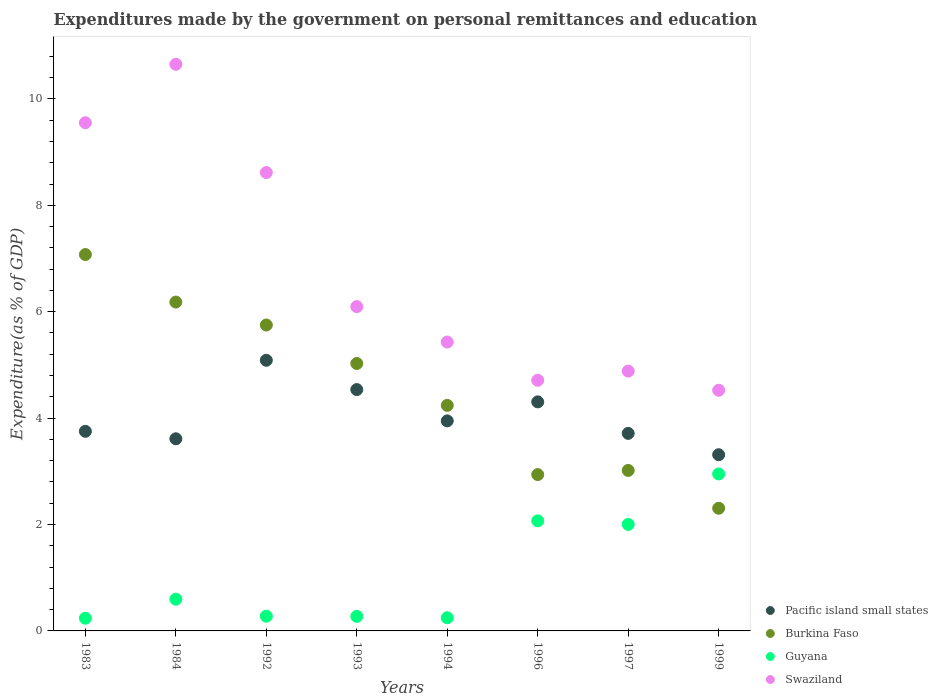How many different coloured dotlines are there?
Your response must be concise. 4. What is the expenditures made by the government on personal remittances and education in Burkina Faso in 1996?
Offer a terse response. 2.94. Across all years, what is the maximum expenditures made by the government on personal remittances and education in Burkina Faso?
Make the answer very short. 7.07. Across all years, what is the minimum expenditures made by the government on personal remittances and education in Burkina Faso?
Give a very brief answer. 2.31. In which year was the expenditures made by the government on personal remittances and education in Burkina Faso minimum?
Provide a succinct answer. 1999. What is the total expenditures made by the government on personal remittances and education in Swaziland in the graph?
Make the answer very short. 54.46. What is the difference between the expenditures made by the government on personal remittances and education in Guyana in 1984 and that in 1996?
Provide a short and direct response. -1.47. What is the difference between the expenditures made by the government on personal remittances and education in Burkina Faso in 1994 and the expenditures made by the government on personal remittances and education in Guyana in 1996?
Provide a succinct answer. 2.17. What is the average expenditures made by the government on personal remittances and education in Guyana per year?
Provide a succinct answer. 1.08. In the year 1983, what is the difference between the expenditures made by the government on personal remittances and education in Burkina Faso and expenditures made by the government on personal remittances and education in Guyana?
Keep it short and to the point. 6.84. What is the ratio of the expenditures made by the government on personal remittances and education in Burkina Faso in 1994 to that in 1996?
Offer a very short reply. 1.44. Is the difference between the expenditures made by the government on personal remittances and education in Burkina Faso in 1983 and 1999 greater than the difference between the expenditures made by the government on personal remittances and education in Guyana in 1983 and 1999?
Offer a terse response. Yes. What is the difference between the highest and the second highest expenditures made by the government on personal remittances and education in Guyana?
Ensure brevity in your answer.  0.88. What is the difference between the highest and the lowest expenditures made by the government on personal remittances and education in Swaziland?
Give a very brief answer. 6.13. In how many years, is the expenditures made by the government on personal remittances and education in Pacific island small states greater than the average expenditures made by the government on personal remittances and education in Pacific island small states taken over all years?
Provide a succinct answer. 3. Is the sum of the expenditures made by the government on personal remittances and education in Pacific island small states in 1984 and 1993 greater than the maximum expenditures made by the government on personal remittances and education in Burkina Faso across all years?
Provide a succinct answer. Yes. Is it the case that in every year, the sum of the expenditures made by the government on personal remittances and education in Swaziland and expenditures made by the government on personal remittances and education in Guyana  is greater than the sum of expenditures made by the government on personal remittances and education in Pacific island small states and expenditures made by the government on personal remittances and education in Burkina Faso?
Offer a very short reply. Yes. Is it the case that in every year, the sum of the expenditures made by the government on personal remittances and education in Guyana and expenditures made by the government on personal remittances and education in Burkina Faso  is greater than the expenditures made by the government on personal remittances and education in Pacific island small states?
Your answer should be very brief. Yes. Does the expenditures made by the government on personal remittances and education in Swaziland monotonically increase over the years?
Keep it short and to the point. No. How many years are there in the graph?
Your answer should be compact. 8. Are the values on the major ticks of Y-axis written in scientific E-notation?
Provide a short and direct response. No. Does the graph contain any zero values?
Keep it short and to the point. No. Does the graph contain grids?
Offer a terse response. No. How many legend labels are there?
Make the answer very short. 4. What is the title of the graph?
Your response must be concise. Expenditures made by the government on personal remittances and education. What is the label or title of the Y-axis?
Your response must be concise. Expenditure(as % of GDP). What is the Expenditure(as % of GDP) in Pacific island small states in 1983?
Your answer should be very brief. 3.75. What is the Expenditure(as % of GDP) of Burkina Faso in 1983?
Ensure brevity in your answer.  7.07. What is the Expenditure(as % of GDP) in Guyana in 1983?
Your answer should be very brief. 0.24. What is the Expenditure(as % of GDP) of Swaziland in 1983?
Offer a terse response. 9.55. What is the Expenditure(as % of GDP) in Pacific island small states in 1984?
Your response must be concise. 3.61. What is the Expenditure(as % of GDP) in Burkina Faso in 1984?
Your response must be concise. 6.18. What is the Expenditure(as % of GDP) of Guyana in 1984?
Provide a succinct answer. 0.6. What is the Expenditure(as % of GDP) in Swaziland in 1984?
Offer a very short reply. 10.65. What is the Expenditure(as % of GDP) in Pacific island small states in 1992?
Provide a succinct answer. 5.09. What is the Expenditure(as % of GDP) in Burkina Faso in 1992?
Offer a very short reply. 5.75. What is the Expenditure(as % of GDP) of Guyana in 1992?
Provide a succinct answer. 0.28. What is the Expenditure(as % of GDP) in Swaziland in 1992?
Your answer should be compact. 8.62. What is the Expenditure(as % of GDP) in Pacific island small states in 1993?
Provide a short and direct response. 4.54. What is the Expenditure(as % of GDP) of Burkina Faso in 1993?
Keep it short and to the point. 5.03. What is the Expenditure(as % of GDP) in Guyana in 1993?
Make the answer very short. 0.27. What is the Expenditure(as % of GDP) in Swaziland in 1993?
Ensure brevity in your answer.  6.1. What is the Expenditure(as % of GDP) of Pacific island small states in 1994?
Ensure brevity in your answer.  3.95. What is the Expenditure(as % of GDP) of Burkina Faso in 1994?
Provide a short and direct response. 4.24. What is the Expenditure(as % of GDP) in Guyana in 1994?
Your response must be concise. 0.25. What is the Expenditure(as % of GDP) in Swaziland in 1994?
Keep it short and to the point. 5.43. What is the Expenditure(as % of GDP) of Pacific island small states in 1996?
Keep it short and to the point. 4.31. What is the Expenditure(as % of GDP) of Burkina Faso in 1996?
Offer a very short reply. 2.94. What is the Expenditure(as % of GDP) in Guyana in 1996?
Your answer should be very brief. 2.07. What is the Expenditure(as % of GDP) of Swaziland in 1996?
Give a very brief answer. 4.71. What is the Expenditure(as % of GDP) in Pacific island small states in 1997?
Your answer should be compact. 3.71. What is the Expenditure(as % of GDP) of Burkina Faso in 1997?
Your answer should be compact. 3.02. What is the Expenditure(as % of GDP) in Guyana in 1997?
Your response must be concise. 2. What is the Expenditure(as % of GDP) in Swaziland in 1997?
Your response must be concise. 4.88. What is the Expenditure(as % of GDP) of Pacific island small states in 1999?
Ensure brevity in your answer.  3.31. What is the Expenditure(as % of GDP) of Burkina Faso in 1999?
Your response must be concise. 2.31. What is the Expenditure(as % of GDP) in Guyana in 1999?
Offer a terse response. 2.95. What is the Expenditure(as % of GDP) in Swaziland in 1999?
Make the answer very short. 4.52. Across all years, what is the maximum Expenditure(as % of GDP) of Pacific island small states?
Provide a succinct answer. 5.09. Across all years, what is the maximum Expenditure(as % of GDP) in Burkina Faso?
Make the answer very short. 7.07. Across all years, what is the maximum Expenditure(as % of GDP) of Guyana?
Ensure brevity in your answer.  2.95. Across all years, what is the maximum Expenditure(as % of GDP) of Swaziland?
Provide a succinct answer. 10.65. Across all years, what is the minimum Expenditure(as % of GDP) in Pacific island small states?
Provide a succinct answer. 3.31. Across all years, what is the minimum Expenditure(as % of GDP) in Burkina Faso?
Make the answer very short. 2.31. Across all years, what is the minimum Expenditure(as % of GDP) in Guyana?
Your answer should be very brief. 0.24. Across all years, what is the minimum Expenditure(as % of GDP) in Swaziland?
Provide a succinct answer. 4.52. What is the total Expenditure(as % of GDP) in Pacific island small states in the graph?
Keep it short and to the point. 32.27. What is the total Expenditure(as % of GDP) in Burkina Faso in the graph?
Provide a short and direct response. 36.53. What is the total Expenditure(as % of GDP) in Guyana in the graph?
Provide a short and direct response. 8.66. What is the total Expenditure(as % of GDP) of Swaziland in the graph?
Your response must be concise. 54.46. What is the difference between the Expenditure(as % of GDP) of Pacific island small states in 1983 and that in 1984?
Keep it short and to the point. 0.14. What is the difference between the Expenditure(as % of GDP) in Burkina Faso in 1983 and that in 1984?
Provide a short and direct response. 0.89. What is the difference between the Expenditure(as % of GDP) in Guyana in 1983 and that in 1984?
Ensure brevity in your answer.  -0.36. What is the difference between the Expenditure(as % of GDP) in Swaziland in 1983 and that in 1984?
Provide a succinct answer. -1.1. What is the difference between the Expenditure(as % of GDP) in Pacific island small states in 1983 and that in 1992?
Ensure brevity in your answer.  -1.34. What is the difference between the Expenditure(as % of GDP) in Burkina Faso in 1983 and that in 1992?
Your answer should be compact. 1.32. What is the difference between the Expenditure(as % of GDP) in Guyana in 1983 and that in 1992?
Provide a short and direct response. -0.04. What is the difference between the Expenditure(as % of GDP) in Swaziland in 1983 and that in 1992?
Ensure brevity in your answer.  0.94. What is the difference between the Expenditure(as % of GDP) of Pacific island small states in 1983 and that in 1993?
Provide a succinct answer. -0.78. What is the difference between the Expenditure(as % of GDP) of Burkina Faso in 1983 and that in 1993?
Offer a very short reply. 2.05. What is the difference between the Expenditure(as % of GDP) in Guyana in 1983 and that in 1993?
Make the answer very short. -0.04. What is the difference between the Expenditure(as % of GDP) in Swaziland in 1983 and that in 1993?
Provide a succinct answer. 3.46. What is the difference between the Expenditure(as % of GDP) of Pacific island small states in 1983 and that in 1994?
Ensure brevity in your answer.  -0.2. What is the difference between the Expenditure(as % of GDP) of Burkina Faso in 1983 and that in 1994?
Provide a succinct answer. 2.84. What is the difference between the Expenditure(as % of GDP) in Guyana in 1983 and that in 1994?
Provide a short and direct response. -0.01. What is the difference between the Expenditure(as % of GDP) in Swaziland in 1983 and that in 1994?
Offer a terse response. 4.12. What is the difference between the Expenditure(as % of GDP) of Pacific island small states in 1983 and that in 1996?
Provide a succinct answer. -0.55. What is the difference between the Expenditure(as % of GDP) in Burkina Faso in 1983 and that in 1996?
Offer a terse response. 4.14. What is the difference between the Expenditure(as % of GDP) of Guyana in 1983 and that in 1996?
Give a very brief answer. -1.83. What is the difference between the Expenditure(as % of GDP) in Swaziland in 1983 and that in 1996?
Provide a short and direct response. 4.84. What is the difference between the Expenditure(as % of GDP) in Pacific island small states in 1983 and that in 1997?
Your answer should be compact. 0.04. What is the difference between the Expenditure(as % of GDP) in Burkina Faso in 1983 and that in 1997?
Offer a terse response. 4.06. What is the difference between the Expenditure(as % of GDP) of Guyana in 1983 and that in 1997?
Your answer should be compact. -1.76. What is the difference between the Expenditure(as % of GDP) in Swaziland in 1983 and that in 1997?
Provide a succinct answer. 4.67. What is the difference between the Expenditure(as % of GDP) of Pacific island small states in 1983 and that in 1999?
Offer a terse response. 0.44. What is the difference between the Expenditure(as % of GDP) in Burkina Faso in 1983 and that in 1999?
Give a very brief answer. 4.77. What is the difference between the Expenditure(as % of GDP) in Guyana in 1983 and that in 1999?
Your answer should be compact. -2.71. What is the difference between the Expenditure(as % of GDP) in Swaziland in 1983 and that in 1999?
Provide a short and direct response. 5.03. What is the difference between the Expenditure(as % of GDP) of Pacific island small states in 1984 and that in 1992?
Ensure brevity in your answer.  -1.48. What is the difference between the Expenditure(as % of GDP) in Burkina Faso in 1984 and that in 1992?
Your answer should be very brief. 0.43. What is the difference between the Expenditure(as % of GDP) of Guyana in 1984 and that in 1992?
Your answer should be very brief. 0.32. What is the difference between the Expenditure(as % of GDP) in Swaziland in 1984 and that in 1992?
Your answer should be very brief. 2.04. What is the difference between the Expenditure(as % of GDP) of Pacific island small states in 1984 and that in 1993?
Your answer should be compact. -0.92. What is the difference between the Expenditure(as % of GDP) of Burkina Faso in 1984 and that in 1993?
Your answer should be very brief. 1.15. What is the difference between the Expenditure(as % of GDP) in Guyana in 1984 and that in 1993?
Offer a terse response. 0.32. What is the difference between the Expenditure(as % of GDP) in Swaziland in 1984 and that in 1993?
Provide a short and direct response. 4.55. What is the difference between the Expenditure(as % of GDP) of Pacific island small states in 1984 and that in 1994?
Provide a short and direct response. -0.34. What is the difference between the Expenditure(as % of GDP) of Burkina Faso in 1984 and that in 1994?
Give a very brief answer. 1.94. What is the difference between the Expenditure(as % of GDP) of Guyana in 1984 and that in 1994?
Make the answer very short. 0.35. What is the difference between the Expenditure(as % of GDP) in Swaziland in 1984 and that in 1994?
Your answer should be compact. 5.22. What is the difference between the Expenditure(as % of GDP) in Pacific island small states in 1984 and that in 1996?
Offer a terse response. -0.69. What is the difference between the Expenditure(as % of GDP) in Burkina Faso in 1984 and that in 1996?
Give a very brief answer. 3.24. What is the difference between the Expenditure(as % of GDP) in Guyana in 1984 and that in 1996?
Ensure brevity in your answer.  -1.47. What is the difference between the Expenditure(as % of GDP) of Swaziland in 1984 and that in 1996?
Provide a short and direct response. 5.94. What is the difference between the Expenditure(as % of GDP) of Pacific island small states in 1984 and that in 1997?
Your answer should be compact. -0.1. What is the difference between the Expenditure(as % of GDP) in Burkina Faso in 1984 and that in 1997?
Ensure brevity in your answer.  3.16. What is the difference between the Expenditure(as % of GDP) in Guyana in 1984 and that in 1997?
Give a very brief answer. -1.41. What is the difference between the Expenditure(as % of GDP) of Swaziland in 1984 and that in 1997?
Offer a very short reply. 5.77. What is the difference between the Expenditure(as % of GDP) in Pacific island small states in 1984 and that in 1999?
Give a very brief answer. 0.3. What is the difference between the Expenditure(as % of GDP) in Burkina Faso in 1984 and that in 1999?
Provide a succinct answer. 3.88. What is the difference between the Expenditure(as % of GDP) of Guyana in 1984 and that in 1999?
Keep it short and to the point. -2.35. What is the difference between the Expenditure(as % of GDP) in Swaziland in 1984 and that in 1999?
Offer a terse response. 6.13. What is the difference between the Expenditure(as % of GDP) of Pacific island small states in 1992 and that in 1993?
Your answer should be compact. 0.55. What is the difference between the Expenditure(as % of GDP) of Burkina Faso in 1992 and that in 1993?
Keep it short and to the point. 0.72. What is the difference between the Expenditure(as % of GDP) of Guyana in 1992 and that in 1993?
Your response must be concise. 0. What is the difference between the Expenditure(as % of GDP) of Swaziland in 1992 and that in 1993?
Offer a very short reply. 2.52. What is the difference between the Expenditure(as % of GDP) of Pacific island small states in 1992 and that in 1994?
Offer a terse response. 1.14. What is the difference between the Expenditure(as % of GDP) of Burkina Faso in 1992 and that in 1994?
Your answer should be compact. 1.51. What is the difference between the Expenditure(as % of GDP) of Guyana in 1992 and that in 1994?
Offer a terse response. 0.03. What is the difference between the Expenditure(as % of GDP) of Swaziland in 1992 and that in 1994?
Give a very brief answer. 3.19. What is the difference between the Expenditure(as % of GDP) in Pacific island small states in 1992 and that in 1996?
Offer a terse response. 0.78. What is the difference between the Expenditure(as % of GDP) in Burkina Faso in 1992 and that in 1996?
Make the answer very short. 2.81. What is the difference between the Expenditure(as % of GDP) in Guyana in 1992 and that in 1996?
Your answer should be very brief. -1.79. What is the difference between the Expenditure(as % of GDP) in Swaziland in 1992 and that in 1996?
Provide a succinct answer. 3.9. What is the difference between the Expenditure(as % of GDP) of Pacific island small states in 1992 and that in 1997?
Keep it short and to the point. 1.37. What is the difference between the Expenditure(as % of GDP) in Burkina Faso in 1992 and that in 1997?
Keep it short and to the point. 2.73. What is the difference between the Expenditure(as % of GDP) in Guyana in 1992 and that in 1997?
Offer a terse response. -1.73. What is the difference between the Expenditure(as % of GDP) of Swaziland in 1992 and that in 1997?
Your answer should be very brief. 3.73. What is the difference between the Expenditure(as % of GDP) in Pacific island small states in 1992 and that in 1999?
Keep it short and to the point. 1.78. What is the difference between the Expenditure(as % of GDP) of Burkina Faso in 1992 and that in 1999?
Provide a short and direct response. 3.44. What is the difference between the Expenditure(as % of GDP) of Guyana in 1992 and that in 1999?
Your response must be concise. -2.67. What is the difference between the Expenditure(as % of GDP) in Swaziland in 1992 and that in 1999?
Give a very brief answer. 4.09. What is the difference between the Expenditure(as % of GDP) of Pacific island small states in 1993 and that in 1994?
Give a very brief answer. 0.59. What is the difference between the Expenditure(as % of GDP) of Burkina Faso in 1993 and that in 1994?
Your response must be concise. 0.79. What is the difference between the Expenditure(as % of GDP) in Guyana in 1993 and that in 1994?
Ensure brevity in your answer.  0.03. What is the difference between the Expenditure(as % of GDP) of Swaziland in 1993 and that in 1994?
Make the answer very short. 0.67. What is the difference between the Expenditure(as % of GDP) in Pacific island small states in 1993 and that in 1996?
Provide a short and direct response. 0.23. What is the difference between the Expenditure(as % of GDP) of Burkina Faso in 1993 and that in 1996?
Ensure brevity in your answer.  2.09. What is the difference between the Expenditure(as % of GDP) in Guyana in 1993 and that in 1996?
Offer a very short reply. -1.8. What is the difference between the Expenditure(as % of GDP) of Swaziland in 1993 and that in 1996?
Ensure brevity in your answer.  1.38. What is the difference between the Expenditure(as % of GDP) in Pacific island small states in 1993 and that in 1997?
Your answer should be compact. 0.82. What is the difference between the Expenditure(as % of GDP) of Burkina Faso in 1993 and that in 1997?
Offer a terse response. 2.01. What is the difference between the Expenditure(as % of GDP) of Guyana in 1993 and that in 1997?
Give a very brief answer. -1.73. What is the difference between the Expenditure(as % of GDP) of Swaziland in 1993 and that in 1997?
Give a very brief answer. 1.21. What is the difference between the Expenditure(as % of GDP) in Pacific island small states in 1993 and that in 1999?
Give a very brief answer. 1.22. What is the difference between the Expenditure(as % of GDP) of Burkina Faso in 1993 and that in 1999?
Make the answer very short. 2.72. What is the difference between the Expenditure(as % of GDP) in Guyana in 1993 and that in 1999?
Your answer should be very brief. -2.68. What is the difference between the Expenditure(as % of GDP) of Swaziland in 1993 and that in 1999?
Ensure brevity in your answer.  1.57. What is the difference between the Expenditure(as % of GDP) of Pacific island small states in 1994 and that in 1996?
Ensure brevity in your answer.  -0.36. What is the difference between the Expenditure(as % of GDP) of Burkina Faso in 1994 and that in 1996?
Keep it short and to the point. 1.3. What is the difference between the Expenditure(as % of GDP) of Guyana in 1994 and that in 1996?
Provide a succinct answer. -1.82. What is the difference between the Expenditure(as % of GDP) of Swaziland in 1994 and that in 1996?
Ensure brevity in your answer.  0.72. What is the difference between the Expenditure(as % of GDP) of Pacific island small states in 1994 and that in 1997?
Your answer should be very brief. 0.23. What is the difference between the Expenditure(as % of GDP) in Burkina Faso in 1994 and that in 1997?
Keep it short and to the point. 1.22. What is the difference between the Expenditure(as % of GDP) of Guyana in 1994 and that in 1997?
Offer a terse response. -1.75. What is the difference between the Expenditure(as % of GDP) in Swaziland in 1994 and that in 1997?
Offer a terse response. 0.55. What is the difference between the Expenditure(as % of GDP) in Pacific island small states in 1994 and that in 1999?
Your response must be concise. 0.64. What is the difference between the Expenditure(as % of GDP) in Burkina Faso in 1994 and that in 1999?
Provide a short and direct response. 1.93. What is the difference between the Expenditure(as % of GDP) in Guyana in 1994 and that in 1999?
Ensure brevity in your answer.  -2.7. What is the difference between the Expenditure(as % of GDP) of Swaziland in 1994 and that in 1999?
Your answer should be compact. 0.91. What is the difference between the Expenditure(as % of GDP) in Pacific island small states in 1996 and that in 1997?
Your answer should be very brief. 0.59. What is the difference between the Expenditure(as % of GDP) of Burkina Faso in 1996 and that in 1997?
Provide a succinct answer. -0.08. What is the difference between the Expenditure(as % of GDP) of Guyana in 1996 and that in 1997?
Offer a very short reply. 0.07. What is the difference between the Expenditure(as % of GDP) of Swaziland in 1996 and that in 1997?
Your answer should be compact. -0.17. What is the difference between the Expenditure(as % of GDP) of Burkina Faso in 1996 and that in 1999?
Make the answer very short. 0.63. What is the difference between the Expenditure(as % of GDP) in Guyana in 1996 and that in 1999?
Offer a very short reply. -0.88. What is the difference between the Expenditure(as % of GDP) in Swaziland in 1996 and that in 1999?
Your answer should be very brief. 0.19. What is the difference between the Expenditure(as % of GDP) of Pacific island small states in 1997 and that in 1999?
Provide a short and direct response. 0.4. What is the difference between the Expenditure(as % of GDP) of Burkina Faso in 1997 and that in 1999?
Keep it short and to the point. 0.71. What is the difference between the Expenditure(as % of GDP) of Guyana in 1997 and that in 1999?
Your answer should be very brief. -0.95. What is the difference between the Expenditure(as % of GDP) of Swaziland in 1997 and that in 1999?
Your answer should be very brief. 0.36. What is the difference between the Expenditure(as % of GDP) of Pacific island small states in 1983 and the Expenditure(as % of GDP) of Burkina Faso in 1984?
Your answer should be compact. -2.43. What is the difference between the Expenditure(as % of GDP) in Pacific island small states in 1983 and the Expenditure(as % of GDP) in Guyana in 1984?
Give a very brief answer. 3.16. What is the difference between the Expenditure(as % of GDP) in Pacific island small states in 1983 and the Expenditure(as % of GDP) in Swaziland in 1984?
Keep it short and to the point. -6.9. What is the difference between the Expenditure(as % of GDP) in Burkina Faso in 1983 and the Expenditure(as % of GDP) in Guyana in 1984?
Offer a terse response. 6.48. What is the difference between the Expenditure(as % of GDP) of Burkina Faso in 1983 and the Expenditure(as % of GDP) of Swaziland in 1984?
Your response must be concise. -3.58. What is the difference between the Expenditure(as % of GDP) of Guyana in 1983 and the Expenditure(as % of GDP) of Swaziland in 1984?
Give a very brief answer. -10.41. What is the difference between the Expenditure(as % of GDP) of Pacific island small states in 1983 and the Expenditure(as % of GDP) of Burkina Faso in 1992?
Give a very brief answer. -2. What is the difference between the Expenditure(as % of GDP) of Pacific island small states in 1983 and the Expenditure(as % of GDP) of Guyana in 1992?
Keep it short and to the point. 3.48. What is the difference between the Expenditure(as % of GDP) in Pacific island small states in 1983 and the Expenditure(as % of GDP) in Swaziland in 1992?
Give a very brief answer. -4.86. What is the difference between the Expenditure(as % of GDP) in Burkina Faso in 1983 and the Expenditure(as % of GDP) in Guyana in 1992?
Give a very brief answer. 6.8. What is the difference between the Expenditure(as % of GDP) of Burkina Faso in 1983 and the Expenditure(as % of GDP) of Swaziland in 1992?
Your answer should be very brief. -1.54. What is the difference between the Expenditure(as % of GDP) in Guyana in 1983 and the Expenditure(as % of GDP) in Swaziland in 1992?
Make the answer very short. -8.38. What is the difference between the Expenditure(as % of GDP) in Pacific island small states in 1983 and the Expenditure(as % of GDP) in Burkina Faso in 1993?
Provide a short and direct response. -1.27. What is the difference between the Expenditure(as % of GDP) in Pacific island small states in 1983 and the Expenditure(as % of GDP) in Guyana in 1993?
Give a very brief answer. 3.48. What is the difference between the Expenditure(as % of GDP) of Pacific island small states in 1983 and the Expenditure(as % of GDP) of Swaziland in 1993?
Ensure brevity in your answer.  -2.34. What is the difference between the Expenditure(as % of GDP) in Burkina Faso in 1983 and the Expenditure(as % of GDP) in Guyana in 1993?
Your answer should be very brief. 6.8. What is the difference between the Expenditure(as % of GDP) in Burkina Faso in 1983 and the Expenditure(as % of GDP) in Swaziland in 1993?
Your response must be concise. 0.98. What is the difference between the Expenditure(as % of GDP) in Guyana in 1983 and the Expenditure(as % of GDP) in Swaziland in 1993?
Provide a short and direct response. -5.86. What is the difference between the Expenditure(as % of GDP) in Pacific island small states in 1983 and the Expenditure(as % of GDP) in Burkina Faso in 1994?
Provide a succinct answer. -0.49. What is the difference between the Expenditure(as % of GDP) of Pacific island small states in 1983 and the Expenditure(as % of GDP) of Guyana in 1994?
Ensure brevity in your answer.  3.5. What is the difference between the Expenditure(as % of GDP) of Pacific island small states in 1983 and the Expenditure(as % of GDP) of Swaziland in 1994?
Ensure brevity in your answer.  -1.68. What is the difference between the Expenditure(as % of GDP) in Burkina Faso in 1983 and the Expenditure(as % of GDP) in Guyana in 1994?
Make the answer very short. 6.83. What is the difference between the Expenditure(as % of GDP) of Burkina Faso in 1983 and the Expenditure(as % of GDP) of Swaziland in 1994?
Your response must be concise. 1.64. What is the difference between the Expenditure(as % of GDP) of Guyana in 1983 and the Expenditure(as % of GDP) of Swaziland in 1994?
Keep it short and to the point. -5.19. What is the difference between the Expenditure(as % of GDP) of Pacific island small states in 1983 and the Expenditure(as % of GDP) of Burkina Faso in 1996?
Make the answer very short. 0.81. What is the difference between the Expenditure(as % of GDP) in Pacific island small states in 1983 and the Expenditure(as % of GDP) in Guyana in 1996?
Give a very brief answer. 1.68. What is the difference between the Expenditure(as % of GDP) in Pacific island small states in 1983 and the Expenditure(as % of GDP) in Swaziland in 1996?
Make the answer very short. -0.96. What is the difference between the Expenditure(as % of GDP) in Burkina Faso in 1983 and the Expenditure(as % of GDP) in Guyana in 1996?
Make the answer very short. 5. What is the difference between the Expenditure(as % of GDP) in Burkina Faso in 1983 and the Expenditure(as % of GDP) in Swaziland in 1996?
Make the answer very short. 2.36. What is the difference between the Expenditure(as % of GDP) of Guyana in 1983 and the Expenditure(as % of GDP) of Swaziland in 1996?
Offer a terse response. -4.47. What is the difference between the Expenditure(as % of GDP) of Pacific island small states in 1983 and the Expenditure(as % of GDP) of Burkina Faso in 1997?
Your answer should be compact. 0.74. What is the difference between the Expenditure(as % of GDP) in Pacific island small states in 1983 and the Expenditure(as % of GDP) in Guyana in 1997?
Your answer should be very brief. 1.75. What is the difference between the Expenditure(as % of GDP) in Pacific island small states in 1983 and the Expenditure(as % of GDP) in Swaziland in 1997?
Make the answer very short. -1.13. What is the difference between the Expenditure(as % of GDP) in Burkina Faso in 1983 and the Expenditure(as % of GDP) in Guyana in 1997?
Your response must be concise. 5.07. What is the difference between the Expenditure(as % of GDP) in Burkina Faso in 1983 and the Expenditure(as % of GDP) in Swaziland in 1997?
Offer a very short reply. 2.19. What is the difference between the Expenditure(as % of GDP) in Guyana in 1983 and the Expenditure(as % of GDP) in Swaziland in 1997?
Offer a terse response. -4.65. What is the difference between the Expenditure(as % of GDP) in Pacific island small states in 1983 and the Expenditure(as % of GDP) in Burkina Faso in 1999?
Provide a short and direct response. 1.45. What is the difference between the Expenditure(as % of GDP) in Pacific island small states in 1983 and the Expenditure(as % of GDP) in Guyana in 1999?
Offer a very short reply. 0.8. What is the difference between the Expenditure(as % of GDP) of Pacific island small states in 1983 and the Expenditure(as % of GDP) of Swaziland in 1999?
Give a very brief answer. -0.77. What is the difference between the Expenditure(as % of GDP) in Burkina Faso in 1983 and the Expenditure(as % of GDP) in Guyana in 1999?
Ensure brevity in your answer.  4.12. What is the difference between the Expenditure(as % of GDP) of Burkina Faso in 1983 and the Expenditure(as % of GDP) of Swaziland in 1999?
Keep it short and to the point. 2.55. What is the difference between the Expenditure(as % of GDP) in Guyana in 1983 and the Expenditure(as % of GDP) in Swaziland in 1999?
Your answer should be compact. -4.29. What is the difference between the Expenditure(as % of GDP) in Pacific island small states in 1984 and the Expenditure(as % of GDP) in Burkina Faso in 1992?
Offer a very short reply. -2.14. What is the difference between the Expenditure(as % of GDP) of Pacific island small states in 1984 and the Expenditure(as % of GDP) of Guyana in 1992?
Ensure brevity in your answer.  3.33. What is the difference between the Expenditure(as % of GDP) in Pacific island small states in 1984 and the Expenditure(as % of GDP) in Swaziland in 1992?
Give a very brief answer. -5. What is the difference between the Expenditure(as % of GDP) in Burkina Faso in 1984 and the Expenditure(as % of GDP) in Guyana in 1992?
Ensure brevity in your answer.  5.9. What is the difference between the Expenditure(as % of GDP) in Burkina Faso in 1984 and the Expenditure(as % of GDP) in Swaziland in 1992?
Keep it short and to the point. -2.43. What is the difference between the Expenditure(as % of GDP) of Guyana in 1984 and the Expenditure(as % of GDP) of Swaziland in 1992?
Provide a short and direct response. -8.02. What is the difference between the Expenditure(as % of GDP) in Pacific island small states in 1984 and the Expenditure(as % of GDP) in Burkina Faso in 1993?
Your response must be concise. -1.42. What is the difference between the Expenditure(as % of GDP) in Pacific island small states in 1984 and the Expenditure(as % of GDP) in Guyana in 1993?
Make the answer very short. 3.34. What is the difference between the Expenditure(as % of GDP) in Pacific island small states in 1984 and the Expenditure(as % of GDP) in Swaziland in 1993?
Offer a very short reply. -2.48. What is the difference between the Expenditure(as % of GDP) in Burkina Faso in 1984 and the Expenditure(as % of GDP) in Guyana in 1993?
Make the answer very short. 5.91. What is the difference between the Expenditure(as % of GDP) in Burkina Faso in 1984 and the Expenditure(as % of GDP) in Swaziland in 1993?
Your response must be concise. 0.09. What is the difference between the Expenditure(as % of GDP) in Guyana in 1984 and the Expenditure(as % of GDP) in Swaziland in 1993?
Offer a terse response. -5.5. What is the difference between the Expenditure(as % of GDP) in Pacific island small states in 1984 and the Expenditure(as % of GDP) in Burkina Faso in 1994?
Offer a terse response. -0.63. What is the difference between the Expenditure(as % of GDP) in Pacific island small states in 1984 and the Expenditure(as % of GDP) in Guyana in 1994?
Offer a very short reply. 3.36. What is the difference between the Expenditure(as % of GDP) of Pacific island small states in 1984 and the Expenditure(as % of GDP) of Swaziland in 1994?
Ensure brevity in your answer.  -1.82. What is the difference between the Expenditure(as % of GDP) of Burkina Faso in 1984 and the Expenditure(as % of GDP) of Guyana in 1994?
Keep it short and to the point. 5.93. What is the difference between the Expenditure(as % of GDP) of Burkina Faso in 1984 and the Expenditure(as % of GDP) of Swaziland in 1994?
Provide a short and direct response. 0.75. What is the difference between the Expenditure(as % of GDP) in Guyana in 1984 and the Expenditure(as % of GDP) in Swaziland in 1994?
Offer a very short reply. -4.83. What is the difference between the Expenditure(as % of GDP) of Pacific island small states in 1984 and the Expenditure(as % of GDP) of Burkina Faso in 1996?
Ensure brevity in your answer.  0.67. What is the difference between the Expenditure(as % of GDP) in Pacific island small states in 1984 and the Expenditure(as % of GDP) in Guyana in 1996?
Make the answer very short. 1.54. What is the difference between the Expenditure(as % of GDP) of Pacific island small states in 1984 and the Expenditure(as % of GDP) of Swaziland in 1996?
Make the answer very short. -1.1. What is the difference between the Expenditure(as % of GDP) of Burkina Faso in 1984 and the Expenditure(as % of GDP) of Guyana in 1996?
Offer a terse response. 4.11. What is the difference between the Expenditure(as % of GDP) of Burkina Faso in 1984 and the Expenditure(as % of GDP) of Swaziland in 1996?
Give a very brief answer. 1.47. What is the difference between the Expenditure(as % of GDP) of Guyana in 1984 and the Expenditure(as % of GDP) of Swaziland in 1996?
Provide a short and direct response. -4.12. What is the difference between the Expenditure(as % of GDP) in Pacific island small states in 1984 and the Expenditure(as % of GDP) in Burkina Faso in 1997?
Your answer should be very brief. 0.59. What is the difference between the Expenditure(as % of GDP) in Pacific island small states in 1984 and the Expenditure(as % of GDP) in Guyana in 1997?
Keep it short and to the point. 1.61. What is the difference between the Expenditure(as % of GDP) in Pacific island small states in 1984 and the Expenditure(as % of GDP) in Swaziland in 1997?
Make the answer very short. -1.27. What is the difference between the Expenditure(as % of GDP) in Burkina Faso in 1984 and the Expenditure(as % of GDP) in Guyana in 1997?
Provide a succinct answer. 4.18. What is the difference between the Expenditure(as % of GDP) of Burkina Faso in 1984 and the Expenditure(as % of GDP) of Swaziland in 1997?
Your answer should be very brief. 1.3. What is the difference between the Expenditure(as % of GDP) of Guyana in 1984 and the Expenditure(as % of GDP) of Swaziland in 1997?
Make the answer very short. -4.29. What is the difference between the Expenditure(as % of GDP) in Pacific island small states in 1984 and the Expenditure(as % of GDP) in Burkina Faso in 1999?
Provide a short and direct response. 1.31. What is the difference between the Expenditure(as % of GDP) of Pacific island small states in 1984 and the Expenditure(as % of GDP) of Guyana in 1999?
Offer a terse response. 0.66. What is the difference between the Expenditure(as % of GDP) in Pacific island small states in 1984 and the Expenditure(as % of GDP) in Swaziland in 1999?
Ensure brevity in your answer.  -0.91. What is the difference between the Expenditure(as % of GDP) in Burkina Faso in 1984 and the Expenditure(as % of GDP) in Guyana in 1999?
Your answer should be compact. 3.23. What is the difference between the Expenditure(as % of GDP) in Burkina Faso in 1984 and the Expenditure(as % of GDP) in Swaziland in 1999?
Your answer should be compact. 1.66. What is the difference between the Expenditure(as % of GDP) in Guyana in 1984 and the Expenditure(as % of GDP) in Swaziland in 1999?
Your answer should be very brief. -3.93. What is the difference between the Expenditure(as % of GDP) of Pacific island small states in 1992 and the Expenditure(as % of GDP) of Burkina Faso in 1993?
Provide a short and direct response. 0.06. What is the difference between the Expenditure(as % of GDP) of Pacific island small states in 1992 and the Expenditure(as % of GDP) of Guyana in 1993?
Keep it short and to the point. 4.81. What is the difference between the Expenditure(as % of GDP) of Pacific island small states in 1992 and the Expenditure(as % of GDP) of Swaziland in 1993?
Your answer should be very brief. -1.01. What is the difference between the Expenditure(as % of GDP) of Burkina Faso in 1992 and the Expenditure(as % of GDP) of Guyana in 1993?
Provide a short and direct response. 5.48. What is the difference between the Expenditure(as % of GDP) in Burkina Faso in 1992 and the Expenditure(as % of GDP) in Swaziland in 1993?
Your response must be concise. -0.35. What is the difference between the Expenditure(as % of GDP) of Guyana in 1992 and the Expenditure(as % of GDP) of Swaziland in 1993?
Your response must be concise. -5.82. What is the difference between the Expenditure(as % of GDP) of Pacific island small states in 1992 and the Expenditure(as % of GDP) of Burkina Faso in 1994?
Provide a short and direct response. 0.85. What is the difference between the Expenditure(as % of GDP) of Pacific island small states in 1992 and the Expenditure(as % of GDP) of Guyana in 1994?
Keep it short and to the point. 4.84. What is the difference between the Expenditure(as % of GDP) of Pacific island small states in 1992 and the Expenditure(as % of GDP) of Swaziland in 1994?
Offer a very short reply. -0.34. What is the difference between the Expenditure(as % of GDP) in Burkina Faso in 1992 and the Expenditure(as % of GDP) in Guyana in 1994?
Your answer should be very brief. 5.5. What is the difference between the Expenditure(as % of GDP) of Burkina Faso in 1992 and the Expenditure(as % of GDP) of Swaziland in 1994?
Make the answer very short. 0.32. What is the difference between the Expenditure(as % of GDP) in Guyana in 1992 and the Expenditure(as % of GDP) in Swaziland in 1994?
Offer a terse response. -5.15. What is the difference between the Expenditure(as % of GDP) of Pacific island small states in 1992 and the Expenditure(as % of GDP) of Burkina Faso in 1996?
Keep it short and to the point. 2.15. What is the difference between the Expenditure(as % of GDP) of Pacific island small states in 1992 and the Expenditure(as % of GDP) of Guyana in 1996?
Make the answer very short. 3.02. What is the difference between the Expenditure(as % of GDP) in Pacific island small states in 1992 and the Expenditure(as % of GDP) in Swaziland in 1996?
Ensure brevity in your answer.  0.38. What is the difference between the Expenditure(as % of GDP) of Burkina Faso in 1992 and the Expenditure(as % of GDP) of Guyana in 1996?
Offer a very short reply. 3.68. What is the difference between the Expenditure(as % of GDP) in Burkina Faso in 1992 and the Expenditure(as % of GDP) in Swaziland in 1996?
Your answer should be compact. 1.04. What is the difference between the Expenditure(as % of GDP) of Guyana in 1992 and the Expenditure(as % of GDP) of Swaziland in 1996?
Keep it short and to the point. -4.43. What is the difference between the Expenditure(as % of GDP) of Pacific island small states in 1992 and the Expenditure(as % of GDP) of Burkina Faso in 1997?
Give a very brief answer. 2.07. What is the difference between the Expenditure(as % of GDP) of Pacific island small states in 1992 and the Expenditure(as % of GDP) of Guyana in 1997?
Keep it short and to the point. 3.08. What is the difference between the Expenditure(as % of GDP) in Pacific island small states in 1992 and the Expenditure(as % of GDP) in Swaziland in 1997?
Your answer should be very brief. 0.2. What is the difference between the Expenditure(as % of GDP) of Burkina Faso in 1992 and the Expenditure(as % of GDP) of Guyana in 1997?
Offer a very short reply. 3.75. What is the difference between the Expenditure(as % of GDP) in Burkina Faso in 1992 and the Expenditure(as % of GDP) in Swaziland in 1997?
Keep it short and to the point. 0.87. What is the difference between the Expenditure(as % of GDP) in Guyana in 1992 and the Expenditure(as % of GDP) in Swaziland in 1997?
Provide a succinct answer. -4.61. What is the difference between the Expenditure(as % of GDP) in Pacific island small states in 1992 and the Expenditure(as % of GDP) in Burkina Faso in 1999?
Ensure brevity in your answer.  2.78. What is the difference between the Expenditure(as % of GDP) of Pacific island small states in 1992 and the Expenditure(as % of GDP) of Guyana in 1999?
Offer a terse response. 2.14. What is the difference between the Expenditure(as % of GDP) of Pacific island small states in 1992 and the Expenditure(as % of GDP) of Swaziland in 1999?
Give a very brief answer. 0.56. What is the difference between the Expenditure(as % of GDP) of Burkina Faso in 1992 and the Expenditure(as % of GDP) of Guyana in 1999?
Offer a very short reply. 2.8. What is the difference between the Expenditure(as % of GDP) in Burkina Faso in 1992 and the Expenditure(as % of GDP) in Swaziland in 1999?
Give a very brief answer. 1.23. What is the difference between the Expenditure(as % of GDP) of Guyana in 1992 and the Expenditure(as % of GDP) of Swaziland in 1999?
Provide a succinct answer. -4.25. What is the difference between the Expenditure(as % of GDP) in Pacific island small states in 1993 and the Expenditure(as % of GDP) in Burkina Faso in 1994?
Ensure brevity in your answer.  0.3. What is the difference between the Expenditure(as % of GDP) in Pacific island small states in 1993 and the Expenditure(as % of GDP) in Guyana in 1994?
Make the answer very short. 4.29. What is the difference between the Expenditure(as % of GDP) in Pacific island small states in 1993 and the Expenditure(as % of GDP) in Swaziland in 1994?
Give a very brief answer. -0.89. What is the difference between the Expenditure(as % of GDP) in Burkina Faso in 1993 and the Expenditure(as % of GDP) in Guyana in 1994?
Provide a succinct answer. 4.78. What is the difference between the Expenditure(as % of GDP) of Burkina Faso in 1993 and the Expenditure(as % of GDP) of Swaziland in 1994?
Give a very brief answer. -0.4. What is the difference between the Expenditure(as % of GDP) in Guyana in 1993 and the Expenditure(as % of GDP) in Swaziland in 1994?
Your answer should be compact. -5.16. What is the difference between the Expenditure(as % of GDP) of Pacific island small states in 1993 and the Expenditure(as % of GDP) of Burkina Faso in 1996?
Keep it short and to the point. 1.6. What is the difference between the Expenditure(as % of GDP) in Pacific island small states in 1993 and the Expenditure(as % of GDP) in Guyana in 1996?
Make the answer very short. 2.47. What is the difference between the Expenditure(as % of GDP) of Pacific island small states in 1993 and the Expenditure(as % of GDP) of Swaziland in 1996?
Give a very brief answer. -0.18. What is the difference between the Expenditure(as % of GDP) in Burkina Faso in 1993 and the Expenditure(as % of GDP) in Guyana in 1996?
Make the answer very short. 2.96. What is the difference between the Expenditure(as % of GDP) in Burkina Faso in 1993 and the Expenditure(as % of GDP) in Swaziland in 1996?
Ensure brevity in your answer.  0.32. What is the difference between the Expenditure(as % of GDP) of Guyana in 1993 and the Expenditure(as % of GDP) of Swaziland in 1996?
Your response must be concise. -4.44. What is the difference between the Expenditure(as % of GDP) of Pacific island small states in 1993 and the Expenditure(as % of GDP) of Burkina Faso in 1997?
Keep it short and to the point. 1.52. What is the difference between the Expenditure(as % of GDP) in Pacific island small states in 1993 and the Expenditure(as % of GDP) in Guyana in 1997?
Your response must be concise. 2.53. What is the difference between the Expenditure(as % of GDP) in Pacific island small states in 1993 and the Expenditure(as % of GDP) in Swaziland in 1997?
Offer a very short reply. -0.35. What is the difference between the Expenditure(as % of GDP) of Burkina Faso in 1993 and the Expenditure(as % of GDP) of Guyana in 1997?
Your response must be concise. 3.02. What is the difference between the Expenditure(as % of GDP) in Burkina Faso in 1993 and the Expenditure(as % of GDP) in Swaziland in 1997?
Your answer should be very brief. 0.14. What is the difference between the Expenditure(as % of GDP) in Guyana in 1993 and the Expenditure(as % of GDP) in Swaziland in 1997?
Keep it short and to the point. -4.61. What is the difference between the Expenditure(as % of GDP) of Pacific island small states in 1993 and the Expenditure(as % of GDP) of Burkina Faso in 1999?
Your answer should be very brief. 2.23. What is the difference between the Expenditure(as % of GDP) of Pacific island small states in 1993 and the Expenditure(as % of GDP) of Guyana in 1999?
Your answer should be very brief. 1.59. What is the difference between the Expenditure(as % of GDP) in Pacific island small states in 1993 and the Expenditure(as % of GDP) in Swaziland in 1999?
Your answer should be compact. 0.01. What is the difference between the Expenditure(as % of GDP) of Burkina Faso in 1993 and the Expenditure(as % of GDP) of Guyana in 1999?
Keep it short and to the point. 2.08. What is the difference between the Expenditure(as % of GDP) of Burkina Faso in 1993 and the Expenditure(as % of GDP) of Swaziland in 1999?
Your response must be concise. 0.5. What is the difference between the Expenditure(as % of GDP) of Guyana in 1993 and the Expenditure(as % of GDP) of Swaziland in 1999?
Provide a succinct answer. -4.25. What is the difference between the Expenditure(as % of GDP) in Pacific island small states in 1994 and the Expenditure(as % of GDP) in Burkina Faso in 1996?
Make the answer very short. 1.01. What is the difference between the Expenditure(as % of GDP) in Pacific island small states in 1994 and the Expenditure(as % of GDP) in Guyana in 1996?
Offer a terse response. 1.88. What is the difference between the Expenditure(as % of GDP) of Pacific island small states in 1994 and the Expenditure(as % of GDP) of Swaziland in 1996?
Your answer should be compact. -0.76. What is the difference between the Expenditure(as % of GDP) in Burkina Faso in 1994 and the Expenditure(as % of GDP) in Guyana in 1996?
Offer a terse response. 2.17. What is the difference between the Expenditure(as % of GDP) of Burkina Faso in 1994 and the Expenditure(as % of GDP) of Swaziland in 1996?
Provide a short and direct response. -0.47. What is the difference between the Expenditure(as % of GDP) in Guyana in 1994 and the Expenditure(as % of GDP) in Swaziland in 1996?
Your response must be concise. -4.46. What is the difference between the Expenditure(as % of GDP) in Pacific island small states in 1994 and the Expenditure(as % of GDP) in Burkina Faso in 1997?
Keep it short and to the point. 0.93. What is the difference between the Expenditure(as % of GDP) in Pacific island small states in 1994 and the Expenditure(as % of GDP) in Guyana in 1997?
Your answer should be compact. 1.95. What is the difference between the Expenditure(as % of GDP) in Pacific island small states in 1994 and the Expenditure(as % of GDP) in Swaziland in 1997?
Offer a very short reply. -0.94. What is the difference between the Expenditure(as % of GDP) in Burkina Faso in 1994 and the Expenditure(as % of GDP) in Guyana in 1997?
Your answer should be compact. 2.24. What is the difference between the Expenditure(as % of GDP) in Burkina Faso in 1994 and the Expenditure(as % of GDP) in Swaziland in 1997?
Offer a very short reply. -0.64. What is the difference between the Expenditure(as % of GDP) of Guyana in 1994 and the Expenditure(as % of GDP) of Swaziland in 1997?
Keep it short and to the point. -4.64. What is the difference between the Expenditure(as % of GDP) in Pacific island small states in 1994 and the Expenditure(as % of GDP) in Burkina Faso in 1999?
Your answer should be compact. 1.64. What is the difference between the Expenditure(as % of GDP) in Pacific island small states in 1994 and the Expenditure(as % of GDP) in Swaziland in 1999?
Provide a succinct answer. -0.58. What is the difference between the Expenditure(as % of GDP) in Burkina Faso in 1994 and the Expenditure(as % of GDP) in Guyana in 1999?
Provide a short and direct response. 1.29. What is the difference between the Expenditure(as % of GDP) in Burkina Faso in 1994 and the Expenditure(as % of GDP) in Swaziland in 1999?
Your response must be concise. -0.28. What is the difference between the Expenditure(as % of GDP) of Guyana in 1994 and the Expenditure(as % of GDP) of Swaziland in 1999?
Offer a terse response. -4.28. What is the difference between the Expenditure(as % of GDP) in Pacific island small states in 1996 and the Expenditure(as % of GDP) in Burkina Faso in 1997?
Your answer should be very brief. 1.29. What is the difference between the Expenditure(as % of GDP) in Pacific island small states in 1996 and the Expenditure(as % of GDP) in Guyana in 1997?
Offer a very short reply. 2.3. What is the difference between the Expenditure(as % of GDP) in Pacific island small states in 1996 and the Expenditure(as % of GDP) in Swaziland in 1997?
Your answer should be very brief. -0.58. What is the difference between the Expenditure(as % of GDP) of Burkina Faso in 1996 and the Expenditure(as % of GDP) of Guyana in 1997?
Give a very brief answer. 0.94. What is the difference between the Expenditure(as % of GDP) in Burkina Faso in 1996 and the Expenditure(as % of GDP) in Swaziland in 1997?
Offer a very short reply. -1.95. What is the difference between the Expenditure(as % of GDP) in Guyana in 1996 and the Expenditure(as % of GDP) in Swaziland in 1997?
Provide a short and direct response. -2.81. What is the difference between the Expenditure(as % of GDP) in Pacific island small states in 1996 and the Expenditure(as % of GDP) in Burkina Faso in 1999?
Keep it short and to the point. 2. What is the difference between the Expenditure(as % of GDP) in Pacific island small states in 1996 and the Expenditure(as % of GDP) in Guyana in 1999?
Your answer should be compact. 1.35. What is the difference between the Expenditure(as % of GDP) of Pacific island small states in 1996 and the Expenditure(as % of GDP) of Swaziland in 1999?
Your answer should be compact. -0.22. What is the difference between the Expenditure(as % of GDP) of Burkina Faso in 1996 and the Expenditure(as % of GDP) of Guyana in 1999?
Keep it short and to the point. -0.01. What is the difference between the Expenditure(as % of GDP) in Burkina Faso in 1996 and the Expenditure(as % of GDP) in Swaziland in 1999?
Offer a very short reply. -1.59. What is the difference between the Expenditure(as % of GDP) of Guyana in 1996 and the Expenditure(as % of GDP) of Swaziland in 1999?
Provide a short and direct response. -2.45. What is the difference between the Expenditure(as % of GDP) of Pacific island small states in 1997 and the Expenditure(as % of GDP) of Burkina Faso in 1999?
Ensure brevity in your answer.  1.41. What is the difference between the Expenditure(as % of GDP) in Pacific island small states in 1997 and the Expenditure(as % of GDP) in Guyana in 1999?
Your answer should be very brief. 0.76. What is the difference between the Expenditure(as % of GDP) in Pacific island small states in 1997 and the Expenditure(as % of GDP) in Swaziland in 1999?
Offer a very short reply. -0.81. What is the difference between the Expenditure(as % of GDP) in Burkina Faso in 1997 and the Expenditure(as % of GDP) in Guyana in 1999?
Provide a short and direct response. 0.07. What is the difference between the Expenditure(as % of GDP) in Burkina Faso in 1997 and the Expenditure(as % of GDP) in Swaziland in 1999?
Keep it short and to the point. -1.51. What is the difference between the Expenditure(as % of GDP) in Guyana in 1997 and the Expenditure(as % of GDP) in Swaziland in 1999?
Your answer should be very brief. -2.52. What is the average Expenditure(as % of GDP) in Pacific island small states per year?
Provide a succinct answer. 4.03. What is the average Expenditure(as % of GDP) in Burkina Faso per year?
Make the answer very short. 4.57. What is the average Expenditure(as % of GDP) in Guyana per year?
Your answer should be compact. 1.08. What is the average Expenditure(as % of GDP) of Swaziland per year?
Give a very brief answer. 6.81. In the year 1983, what is the difference between the Expenditure(as % of GDP) in Pacific island small states and Expenditure(as % of GDP) in Burkina Faso?
Offer a terse response. -3.32. In the year 1983, what is the difference between the Expenditure(as % of GDP) in Pacific island small states and Expenditure(as % of GDP) in Guyana?
Your response must be concise. 3.51. In the year 1983, what is the difference between the Expenditure(as % of GDP) of Pacific island small states and Expenditure(as % of GDP) of Swaziland?
Give a very brief answer. -5.8. In the year 1983, what is the difference between the Expenditure(as % of GDP) in Burkina Faso and Expenditure(as % of GDP) in Guyana?
Offer a very short reply. 6.84. In the year 1983, what is the difference between the Expenditure(as % of GDP) in Burkina Faso and Expenditure(as % of GDP) in Swaziland?
Your answer should be very brief. -2.48. In the year 1983, what is the difference between the Expenditure(as % of GDP) of Guyana and Expenditure(as % of GDP) of Swaziland?
Your answer should be compact. -9.31. In the year 1984, what is the difference between the Expenditure(as % of GDP) of Pacific island small states and Expenditure(as % of GDP) of Burkina Faso?
Provide a succinct answer. -2.57. In the year 1984, what is the difference between the Expenditure(as % of GDP) of Pacific island small states and Expenditure(as % of GDP) of Guyana?
Keep it short and to the point. 3.02. In the year 1984, what is the difference between the Expenditure(as % of GDP) in Pacific island small states and Expenditure(as % of GDP) in Swaziland?
Give a very brief answer. -7.04. In the year 1984, what is the difference between the Expenditure(as % of GDP) in Burkina Faso and Expenditure(as % of GDP) in Guyana?
Offer a very short reply. 5.58. In the year 1984, what is the difference between the Expenditure(as % of GDP) of Burkina Faso and Expenditure(as % of GDP) of Swaziland?
Ensure brevity in your answer.  -4.47. In the year 1984, what is the difference between the Expenditure(as % of GDP) of Guyana and Expenditure(as % of GDP) of Swaziland?
Offer a very short reply. -10.05. In the year 1992, what is the difference between the Expenditure(as % of GDP) of Pacific island small states and Expenditure(as % of GDP) of Burkina Faso?
Ensure brevity in your answer.  -0.66. In the year 1992, what is the difference between the Expenditure(as % of GDP) in Pacific island small states and Expenditure(as % of GDP) in Guyana?
Your answer should be compact. 4.81. In the year 1992, what is the difference between the Expenditure(as % of GDP) in Pacific island small states and Expenditure(as % of GDP) in Swaziland?
Make the answer very short. -3.53. In the year 1992, what is the difference between the Expenditure(as % of GDP) in Burkina Faso and Expenditure(as % of GDP) in Guyana?
Make the answer very short. 5.47. In the year 1992, what is the difference between the Expenditure(as % of GDP) of Burkina Faso and Expenditure(as % of GDP) of Swaziland?
Provide a short and direct response. -2.87. In the year 1992, what is the difference between the Expenditure(as % of GDP) in Guyana and Expenditure(as % of GDP) in Swaziland?
Offer a terse response. -8.34. In the year 1993, what is the difference between the Expenditure(as % of GDP) in Pacific island small states and Expenditure(as % of GDP) in Burkina Faso?
Your response must be concise. -0.49. In the year 1993, what is the difference between the Expenditure(as % of GDP) in Pacific island small states and Expenditure(as % of GDP) in Guyana?
Ensure brevity in your answer.  4.26. In the year 1993, what is the difference between the Expenditure(as % of GDP) in Pacific island small states and Expenditure(as % of GDP) in Swaziland?
Your response must be concise. -1.56. In the year 1993, what is the difference between the Expenditure(as % of GDP) of Burkina Faso and Expenditure(as % of GDP) of Guyana?
Offer a terse response. 4.75. In the year 1993, what is the difference between the Expenditure(as % of GDP) in Burkina Faso and Expenditure(as % of GDP) in Swaziland?
Provide a short and direct response. -1.07. In the year 1993, what is the difference between the Expenditure(as % of GDP) in Guyana and Expenditure(as % of GDP) in Swaziland?
Provide a succinct answer. -5.82. In the year 1994, what is the difference between the Expenditure(as % of GDP) in Pacific island small states and Expenditure(as % of GDP) in Burkina Faso?
Provide a short and direct response. -0.29. In the year 1994, what is the difference between the Expenditure(as % of GDP) of Pacific island small states and Expenditure(as % of GDP) of Guyana?
Provide a short and direct response. 3.7. In the year 1994, what is the difference between the Expenditure(as % of GDP) in Pacific island small states and Expenditure(as % of GDP) in Swaziland?
Provide a succinct answer. -1.48. In the year 1994, what is the difference between the Expenditure(as % of GDP) in Burkina Faso and Expenditure(as % of GDP) in Guyana?
Your answer should be compact. 3.99. In the year 1994, what is the difference between the Expenditure(as % of GDP) of Burkina Faso and Expenditure(as % of GDP) of Swaziland?
Make the answer very short. -1.19. In the year 1994, what is the difference between the Expenditure(as % of GDP) of Guyana and Expenditure(as % of GDP) of Swaziland?
Your response must be concise. -5.18. In the year 1996, what is the difference between the Expenditure(as % of GDP) of Pacific island small states and Expenditure(as % of GDP) of Burkina Faso?
Offer a very short reply. 1.37. In the year 1996, what is the difference between the Expenditure(as % of GDP) in Pacific island small states and Expenditure(as % of GDP) in Guyana?
Provide a short and direct response. 2.24. In the year 1996, what is the difference between the Expenditure(as % of GDP) of Pacific island small states and Expenditure(as % of GDP) of Swaziland?
Your answer should be compact. -0.41. In the year 1996, what is the difference between the Expenditure(as % of GDP) in Burkina Faso and Expenditure(as % of GDP) in Guyana?
Make the answer very short. 0.87. In the year 1996, what is the difference between the Expenditure(as % of GDP) in Burkina Faso and Expenditure(as % of GDP) in Swaziland?
Your answer should be compact. -1.77. In the year 1996, what is the difference between the Expenditure(as % of GDP) of Guyana and Expenditure(as % of GDP) of Swaziland?
Provide a short and direct response. -2.64. In the year 1997, what is the difference between the Expenditure(as % of GDP) of Pacific island small states and Expenditure(as % of GDP) of Burkina Faso?
Offer a very short reply. 0.7. In the year 1997, what is the difference between the Expenditure(as % of GDP) of Pacific island small states and Expenditure(as % of GDP) of Guyana?
Your answer should be very brief. 1.71. In the year 1997, what is the difference between the Expenditure(as % of GDP) of Pacific island small states and Expenditure(as % of GDP) of Swaziland?
Provide a short and direct response. -1.17. In the year 1997, what is the difference between the Expenditure(as % of GDP) in Burkina Faso and Expenditure(as % of GDP) in Guyana?
Offer a terse response. 1.01. In the year 1997, what is the difference between the Expenditure(as % of GDP) in Burkina Faso and Expenditure(as % of GDP) in Swaziland?
Ensure brevity in your answer.  -1.87. In the year 1997, what is the difference between the Expenditure(as % of GDP) of Guyana and Expenditure(as % of GDP) of Swaziland?
Give a very brief answer. -2.88. In the year 1999, what is the difference between the Expenditure(as % of GDP) of Pacific island small states and Expenditure(as % of GDP) of Burkina Faso?
Ensure brevity in your answer.  1.01. In the year 1999, what is the difference between the Expenditure(as % of GDP) in Pacific island small states and Expenditure(as % of GDP) in Guyana?
Make the answer very short. 0.36. In the year 1999, what is the difference between the Expenditure(as % of GDP) in Pacific island small states and Expenditure(as % of GDP) in Swaziland?
Your response must be concise. -1.21. In the year 1999, what is the difference between the Expenditure(as % of GDP) of Burkina Faso and Expenditure(as % of GDP) of Guyana?
Offer a terse response. -0.65. In the year 1999, what is the difference between the Expenditure(as % of GDP) of Burkina Faso and Expenditure(as % of GDP) of Swaziland?
Provide a short and direct response. -2.22. In the year 1999, what is the difference between the Expenditure(as % of GDP) in Guyana and Expenditure(as % of GDP) in Swaziland?
Your response must be concise. -1.57. What is the ratio of the Expenditure(as % of GDP) of Pacific island small states in 1983 to that in 1984?
Provide a succinct answer. 1.04. What is the ratio of the Expenditure(as % of GDP) in Burkina Faso in 1983 to that in 1984?
Your answer should be compact. 1.14. What is the ratio of the Expenditure(as % of GDP) in Guyana in 1983 to that in 1984?
Offer a terse response. 0.4. What is the ratio of the Expenditure(as % of GDP) of Swaziland in 1983 to that in 1984?
Offer a terse response. 0.9. What is the ratio of the Expenditure(as % of GDP) of Pacific island small states in 1983 to that in 1992?
Provide a short and direct response. 0.74. What is the ratio of the Expenditure(as % of GDP) of Burkina Faso in 1983 to that in 1992?
Provide a short and direct response. 1.23. What is the ratio of the Expenditure(as % of GDP) of Guyana in 1983 to that in 1992?
Make the answer very short. 0.86. What is the ratio of the Expenditure(as % of GDP) of Swaziland in 1983 to that in 1992?
Provide a succinct answer. 1.11. What is the ratio of the Expenditure(as % of GDP) of Pacific island small states in 1983 to that in 1993?
Make the answer very short. 0.83. What is the ratio of the Expenditure(as % of GDP) of Burkina Faso in 1983 to that in 1993?
Your response must be concise. 1.41. What is the ratio of the Expenditure(as % of GDP) in Guyana in 1983 to that in 1993?
Your answer should be very brief. 0.87. What is the ratio of the Expenditure(as % of GDP) of Swaziland in 1983 to that in 1993?
Ensure brevity in your answer.  1.57. What is the ratio of the Expenditure(as % of GDP) in Pacific island small states in 1983 to that in 1994?
Your response must be concise. 0.95. What is the ratio of the Expenditure(as % of GDP) of Burkina Faso in 1983 to that in 1994?
Offer a very short reply. 1.67. What is the ratio of the Expenditure(as % of GDP) of Guyana in 1983 to that in 1994?
Provide a short and direct response. 0.96. What is the ratio of the Expenditure(as % of GDP) of Swaziland in 1983 to that in 1994?
Provide a succinct answer. 1.76. What is the ratio of the Expenditure(as % of GDP) of Pacific island small states in 1983 to that in 1996?
Keep it short and to the point. 0.87. What is the ratio of the Expenditure(as % of GDP) of Burkina Faso in 1983 to that in 1996?
Your answer should be compact. 2.41. What is the ratio of the Expenditure(as % of GDP) in Guyana in 1983 to that in 1996?
Offer a terse response. 0.12. What is the ratio of the Expenditure(as % of GDP) of Swaziland in 1983 to that in 1996?
Your response must be concise. 2.03. What is the ratio of the Expenditure(as % of GDP) of Pacific island small states in 1983 to that in 1997?
Provide a short and direct response. 1.01. What is the ratio of the Expenditure(as % of GDP) in Burkina Faso in 1983 to that in 1997?
Provide a short and direct response. 2.35. What is the ratio of the Expenditure(as % of GDP) in Guyana in 1983 to that in 1997?
Your answer should be compact. 0.12. What is the ratio of the Expenditure(as % of GDP) in Swaziland in 1983 to that in 1997?
Offer a terse response. 1.96. What is the ratio of the Expenditure(as % of GDP) of Pacific island small states in 1983 to that in 1999?
Your answer should be very brief. 1.13. What is the ratio of the Expenditure(as % of GDP) in Burkina Faso in 1983 to that in 1999?
Offer a terse response. 3.07. What is the ratio of the Expenditure(as % of GDP) in Guyana in 1983 to that in 1999?
Keep it short and to the point. 0.08. What is the ratio of the Expenditure(as % of GDP) in Swaziland in 1983 to that in 1999?
Your response must be concise. 2.11. What is the ratio of the Expenditure(as % of GDP) in Pacific island small states in 1984 to that in 1992?
Give a very brief answer. 0.71. What is the ratio of the Expenditure(as % of GDP) in Burkina Faso in 1984 to that in 1992?
Provide a succinct answer. 1.07. What is the ratio of the Expenditure(as % of GDP) in Guyana in 1984 to that in 1992?
Offer a very short reply. 2.15. What is the ratio of the Expenditure(as % of GDP) in Swaziland in 1984 to that in 1992?
Offer a terse response. 1.24. What is the ratio of the Expenditure(as % of GDP) in Pacific island small states in 1984 to that in 1993?
Give a very brief answer. 0.8. What is the ratio of the Expenditure(as % of GDP) in Burkina Faso in 1984 to that in 1993?
Your response must be concise. 1.23. What is the ratio of the Expenditure(as % of GDP) in Guyana in 1984 to that in 1993?
Ensure brevity in your answer.  2.18. What is the ratio of the Expenditure(as % of GDP) in Swaziland in 1984 to that in 1993?
Keep it short and to the point. 1.75. What is the ratio of the Expenditure(as % of GDP) of Pacific island small states in 1984 to that in 1994?
Offer a very short reply. 0.91. What is the ratio of the Expenditure(as % of GDP) of Burkina Faso in 1984 to that in 1994?
Make the answer very short. 1.46. What is the ratio of the Expenditure(as % of GDP) in Guyana in 1984 to that in 1994?
Keep it short and to the point. 2.41. What is the ratio of the Expenditure(as % of GDP) in Swaziland in 1984 to that in 1994?
Keep it short and to the point. 1.96. What is the ratio of the Expenditure(as % of GDP) in Pacific island small states in 1984 to that in 1996?
Make the answer very short. 0.84. What is the ratio of the Expenditure(as % of GDP) of Burkina Faso in 1984 to that in 1996?
Ensure brevity in your answer.  2.1. What is the ratio of the Expenditure(as % of GDP) in Guyana in 1984 to that in 1996?
Offer a terse response. 0.29. What is the ratio of the Expenditure(as % of GDP) in Swaziland in 1984 to that in 1996?
Your response must be concise. 2.26. What is the ratio of the Expenditure(as % of GDP) of Pacific island small states in 1984 to that in 1997?
Ensure brevity in your answer.  0.97. What is the ratio of the Expenditure(as % of GDP) of Burkina Faso in 1984 to that in 1997?
Your answer should be compact. 2.05. What is the ratio of the Expenditure(as % of GDP) of Guyana in 1984 to that in 1997?
Offer a very short reply. 0.3. What is the ratio of the Expenditure(as % of GDP) of Swaziland in 1984 to that in 1997?
Make the answer very short. 2.18. What is the ratio of the Expenditure(as % of GDP) in Pacific island small states in 1984 to that in 1999?
Your answer should be compact. 1.09. What is the ratio of the Expenditure(as % of GDP) of Burkina Faso in 1984 to that in 1999?
Offer a terse response. 2.68. What is the ratio of the Expenditure(as % of GDP) in Guyana in 1984 to that in 1999?
Offer a very short reply. 0.2. What is the ratio of the Expenditure(as % of GDP) of Swaziland in 1984 to that in 1999?
Your answer should be very brief. 2.35. What is the ratio of the Expenditure(as % of GDP) of Pacific island small states in 1992 to that in 1993?
Provide a succinct answer. 1.12. What is the ratio of the Expenditure(as % of GDP) in Burkina Faso in 1992 to that in 1993?
Keep it short and to the point. 1.14. What is the ratio of the Expenditure(as % of GDP) in Guyana in 1992 to that in 1993?
Give a very brief answer. 1.01. What is the ratio of the Expenditure(as % of GDP) of Swaziland in 1992 to that in 1993?
Offer a very short reply. 1.41. What is the ratio of the Expenditure(as % of GDP) in Pacific island small states in 1992 to that in 1994?
Your response must be concise. 1.29. What is the ratio of the Expenditure(as % of GDP) in Burkina Faso in 1992 to that in 1994?
Give a very brief answer. 1.36. What is the ratio of the Expenditure(as % of GDP) in Guyana in 1992 to that in 1994?
Provide a succinct answer. 1.12. What is the ratio of the Expenditure(as % of GDP) in Swaziland in 1992 to that in 1994?
Keep it short and to the point. 1.59. What is the ratio of the Expenditure(as % of GDP) in Pacific island small states in 1992 to that in 1996?
Offer a terse response. 1.18. What is the ratio of the Expenditure(as % of GDP) in Burkina Faso in 1992 to that in 1996?
Your answer should be very brief. 1.96. What is the ratio of the Expenditure(as % of GDP) of Guyana in 1992 to that in 1996?
Provide a succinct answer. 0.13. What is the ratio of the Expenditure(as % of GDP) in Swaziland in 1992 to that in 1996?
Your answer should be compact. 1.83. What is the ratio of the Expenditure(as % of GDP) in Pacific island small states in 1992 to that in 1997?
Keep it short and to the point. 1.37. What is the ratio of the Expenditure(as % of GDP) in Burkina Faso in 1992 to that in 1997?
Your answer should be very brief. 1.91. What is the ratio of the Expenditure(as % of GDP) of Guyana in 1992 to that in 1997?
Your response must be concise. 0.14. What is the ratio of the Expenditure(as % of GDP) in Swaziland in 1992 to that in 1997?
Make the answer very short. 1.76. What is the ratio of the Expenditure(as % of GDP) of Pacific island small states in 1992 to that in 1999?
Your response must be concise. 1.54. What is the ratio of the Expenditure(as % of GDP) of Burkina Faso in 1992 to that in 1999?
Offer a very short reply. 2.49. What is the ratio of the Expenditure(as % of GDP) in Guyana in 1992 to that in 1999?
Make the answer very short. 0.09. What is the ratio of the Expenditure(as % of GDP) of Swaziland in 1992 to that in 1999?
Give a very brief answer. 1.9. What is the ratio of the Expenditure(as % of GDP) of Pacific island small states in 1993 to that in 1994?
Provide a succinct answer. 1.15. What is the ratio of the Expenditure(as % of GDP) in Burkina Faso in 1993 to that in 1994?
Make the answer very short. 1.19. What is the ratio of the Expenditure(as % of GDP) in Guyana in 1993 to that in 1994?
Ensure brevity in your answer.  1.1. What is the ratio of the Expenditure(as % of GDP) in Swaziland in 1993 to that in 1994?
Give a very brief answer. 1.12. What is the ratio of the Expenditure(as % of GDP) in Pacific island small states in 1993 to that in 1996?
Keep it short and to the point. 1.05. What is the ratio of the Expenditure(as % of GDP) in Burkina Faso in 1993 to that in 1996?
Give a very brief answer. 1.71. What is the ratio of the Expenditure(as % of GDP) in Guyana in 1993 to that in 1996?
Provide a succinct answer. 0.13. What is the ratio of the Expenditure(as % of GDP) of Swaziland in 1993 to that in 1996?
Make the answer very short. 1.29. What is the ratio of the Expenditure(as % of GDP) of Pacific island small states in 1993 to that in 1997?
Provide a succinct answer. 1.22. What is the ratio of the Expenditure(as % of GDP) of Burkina Faso in 1993 to that in 1997?
Provide a succinct answer. 1.67. What is the ratio of the Expenditure(as % of GDP) in Guyana in 1993 to that in 1997?
Make the answer very short. 0.14. What is the ratio of the Expenditure(as % of GDP) of Swaziland in 1993 to that in 1997?
Your answer should be very brief. 1.25. What is the ratio of the Expenditure(as % of GDP) of Pacific island small states in 1993 to that in 1999?
Keep it short and to the point. 1.37. What is the ratio of the Expenditure(as % of GDP) in Burkina Faso in 1993 to that in 1999?
Your response must be concise. 2.18. What is the ratio of the Expenditure(as % of GDP) of Guyana in 1993 to that in 1999?
Give a very brief answer. 0.09. What is the ratio of the Expenditure(as % of GDP) of Swaziland in 1993 to that in 1999?
Your response must be concise. 1.35. What is the ratio of the Expenditure(as % of GDP) in Pacific island small states in 1994 to that in 1996?
Offer a terse response. 0.92. What is the ratio of the Expenditure(as % of GDP) of Burkina Faso in 1994 to that in 1996?
Provide a succinct answer. 1.44. What is the ratio of the Expenditure(as % of GDP) of Guyana in 1994 to that in 1996?
Give a very brief answer. 0.12. What is the ratio of the Expenditure(as % of GDP) of Swaziland in 1994 to that in 1996?
Keep it short and to the point. 1.15. What is the ratio of the Expenditure(as % of GDP) of Pacific island small states in 1994 to that in 1997?
Your answer should be very brief. 1.06. What is the ratio of the Expenditure(as % of GDP) in Burkina Faso in 1994 to that in 1997?
Keep it short and to the point. 1.41. What is the ratio of the Expenditure(as % of GDP) of Guyana in 1994 to that in 1997?
Give a very brief answer. 0.12. What is the ratio of the Expenditure(as % of GDP) in Swaziland in 1994 to that in 1997?
Provide a short and direct response. 1.11. What is the ratio of the Expenditure(as % of GDP) of Pacific island small states in 1994 to that in 1999?
Make the answer very short. 1.19. What is the ratio of the Expenditure(as % of GDP) in Burkina Faso in 1994 to that in 1999?
Offer a very short reply. 1.84. What is the ratio of the Expenditure(as % of GDP) of Guyana in 1994 to that in 1999?
Ensure brevity in your answer.  0.08. What is the ratio of the Expenditure(as % of GDP) of Swaziland in 1994 to that in 1999?
Your response must be concise. 1.2. What is the ratio of the Expenditure(as % of GDP) in Pacific island small states in 1996 to that in 1997?
Provide a short and direct response. 1.16. What is the ratio of the Expenditure(as % of GDP) in Burkina Faso in 1996 to that in 1997?
Offer a terse response. 0.97. What is the ratio of the Expenditure(as % of GDP) in Guyana in 1996 to that in 1997?
Provide a short and direct response. 1.03. What is the ratio of the Expenditure(as % of GDP) in Swaziland in 1996 to that in 1997?
Ensure brevity in your answer.  0.96. What is the ratio of the Expenditure(as % of GDP) of Burkina Faso in 1996 to that in 1999?
Provide a succinct answer. 1.27. What is the ratio of the Expenditure(as % of GDP) in Guyana in 1996 to that in 1999?
Keep it short and to the point. 0.7. What is the ratio of the Expenditure(as % of GDP) of Swaziland in 1996 to that in 1999?
Offer a very short reply. 1.04. What is the ratio of the Expenditure(as % of GDP) of Pacific island small states in 1997 to that in 1999?
Your answer should be very brief. 1.12. What is the ratio of the Expenditure(as % of GDP) in Burkina Faso in 1997 to that in 1999?
Provide a succinct answer. 1.31. What is the ratio of the Expenditure(as % of GDP) of Guyana in 1997 to that in 1999?
Your response must be concise. 0.68. What is the ratio of the Expenditure(as % of GDP) of Swaziland in 1997 to that in 1999?
Ensure brevity in your answer.  1.08. What is the difference between the highest and the second highest Expenditure(as % of GDP) of Pacific island small states?
Provide a succinct answer. 0.55. What is the difference between the highest and the second highest Expenditure(as % of GDP) in Burkina Faso?
Your answer should be very brief. 0.89. What is the difference between the highest and the second highest Expenditure(as % of GDP) of Guyana?
Ensure brevity in your answer.  0.88. What is the difference between the highest and the second highest Expenditure(as % of GDP) in Swaziland?
Make the answer very short. 1.1. What is the difference between the highest and the lowest Expenditure(as % of GDP) in Pacific island small states?
Your response must be concise. 1.78. What is the difference between the highest and the lowest Expenditure(as % of GDP) of Burkina Faso?
Keep it short and to the point. 4.77. What is the difference between the highest and the lowest Expenditure(as % of GDP) in Guyana?
Offer a terse response. 2.71. What is the difference between the highest and the lowest Expenditure(as % of GDP) in Swaziland?
Your response must be concise. 6.13. 